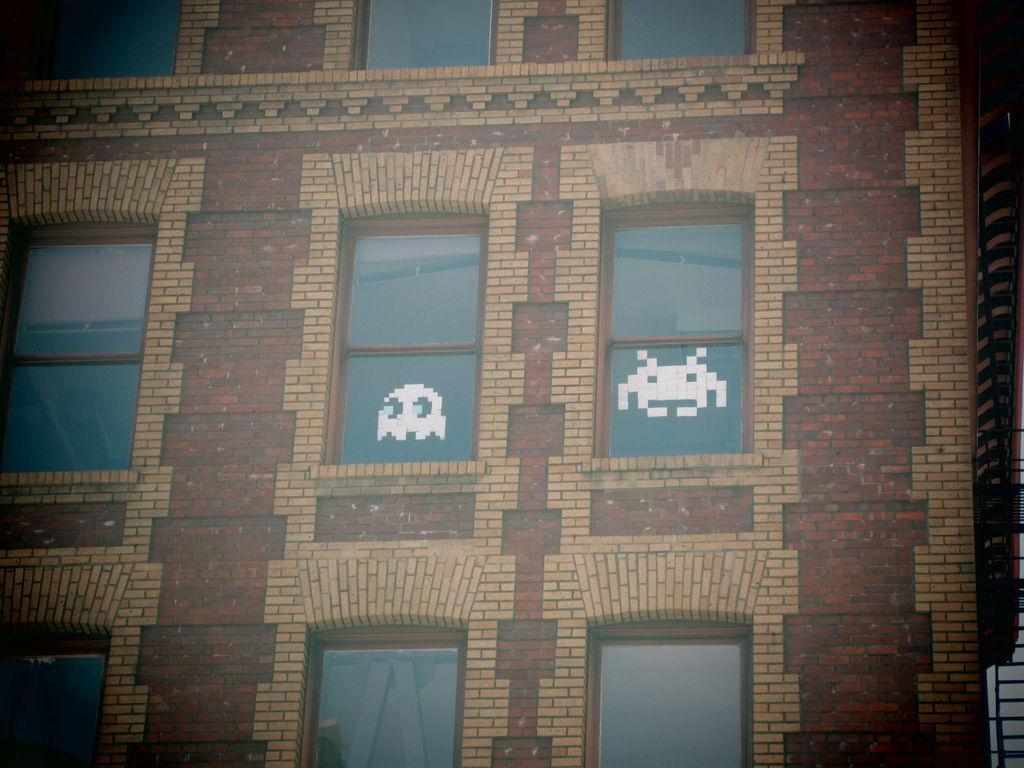What structure is present in the image? There is a building in the image. What feature can be observed on the building? The building has windows. Are there any lawyers or fairies visible in the image? There are no lawyers or fairies present in the image; it only features a building with windows. What type of material is the building made of in the image? The provided facts do not mention the material of the building, so it cannot be determined from the image. 